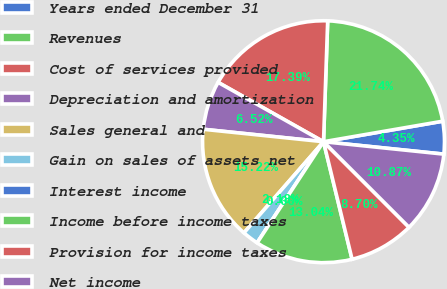Convert chart to OTSL. <chart><loc_0><loc_0><loc_500><loc_500><pie_chart><fcel>Years ended December 31<fcel>Revenues<fcel>Cost of services provided<fcel>Depreciation and amortization<fcel>Sales general and<fcel>Gain on sales of assets net<fcel>Interest income<fcel>Income before income taxes<fcel>Provision for income taxes<fcel>Net income<nl><fcel>4.35%<fcel>21.74%<fcel>17.39%<fcel>6.52%<fcel>15.22%<fcel>2.18%<fcel>0.0%<fcel>13.04%<fcel>8.7%<fcel>10.87%<nl></chart> 